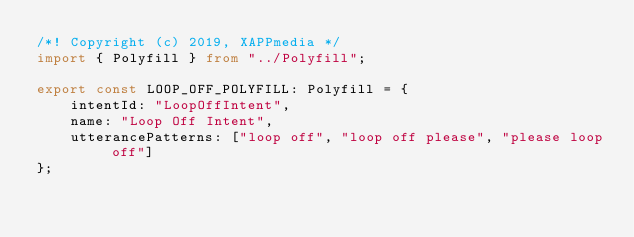Convert code to text. <code><loc_0><loc_0><loc_500><loc_500><_TypeScript_>/*! Copyright (c) 2019, XAPPmedia */
import { Polyfill } from "../Polyfill";

export const LOOP_OFF_POLYFILL: Polyfill = {
    intentId: "LoopOffIntent",
    name: "Loop Off Intent",
    utterancePatterns: ["loop off", "loop off please", "please loop off"]
};
</code> 